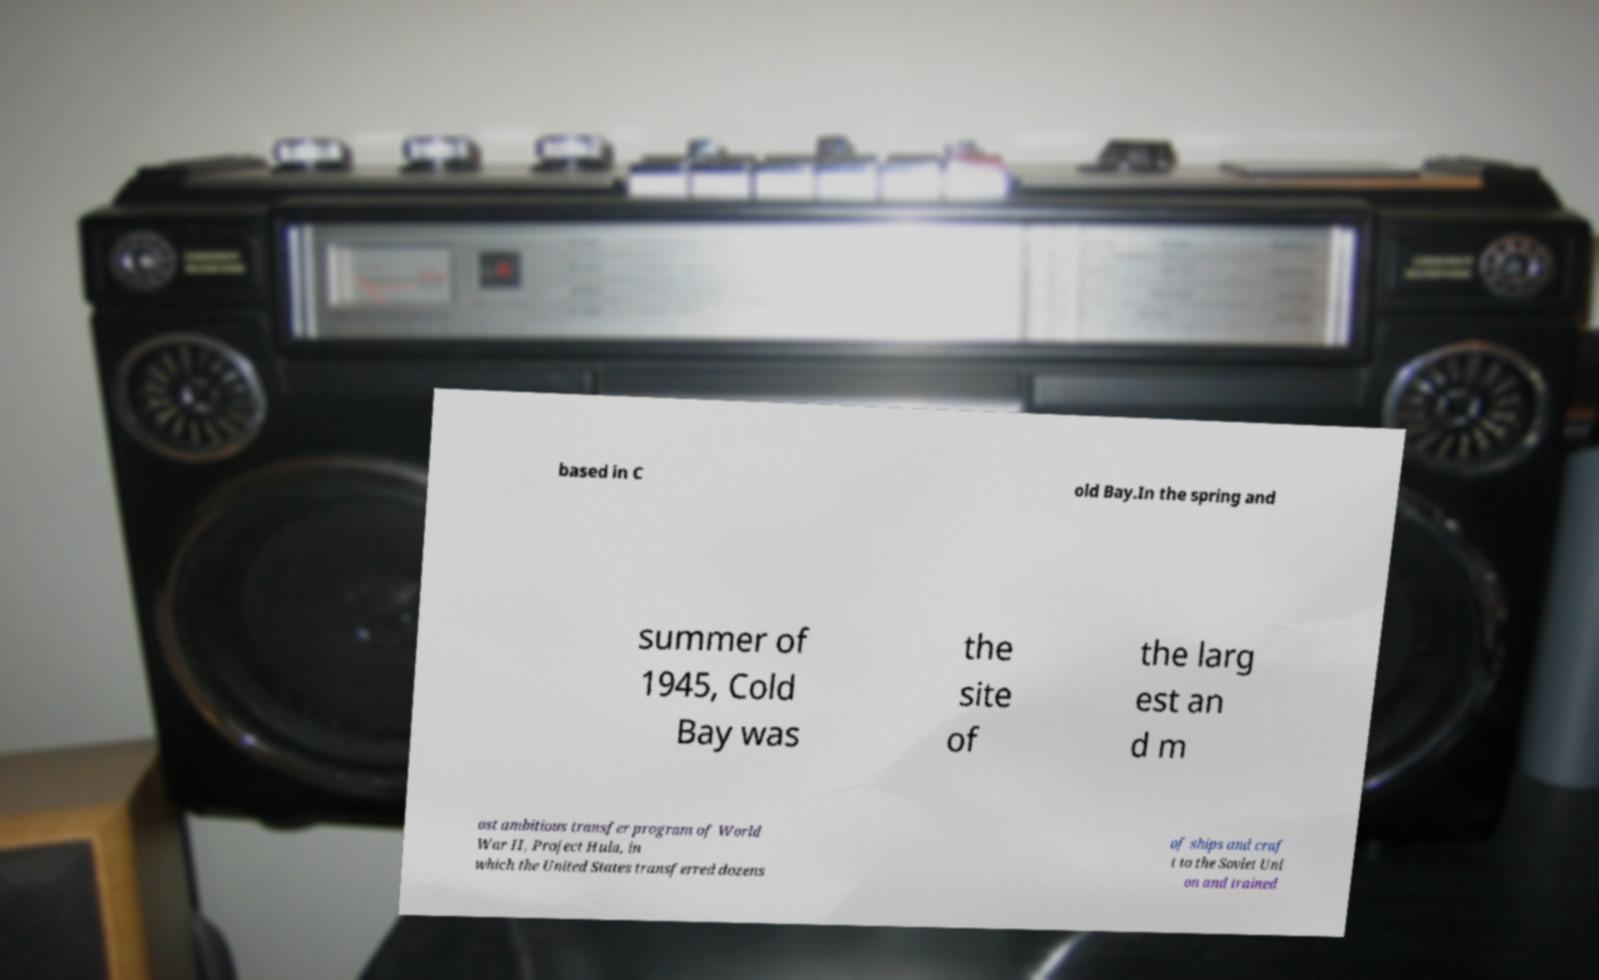What messages or text are displayed in this image? I need them in a readable, typed format. based in C old Bay.In the spring and summer of 1945, Cold Bay was the site of the larg est an d m ost ambitious transfer program of World War II, Project Hula, in which the United States transferred dozens of ships and craf t to the Soviet Uni on and trained 